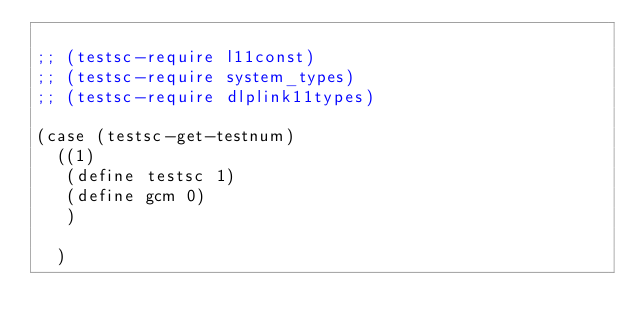Convert code to text. <code><loc_0><loc_0><loc_500><loc_500><_Scheme_>
;; (testsc-require l11const)
;; (testsc-require system_types)
;; (testsc-require dlplink11types)

(case (testsc-get-testnum)
  ((1)
   (define testsc 1)
   (define gcm 0)
   )
  
  )

</code> 